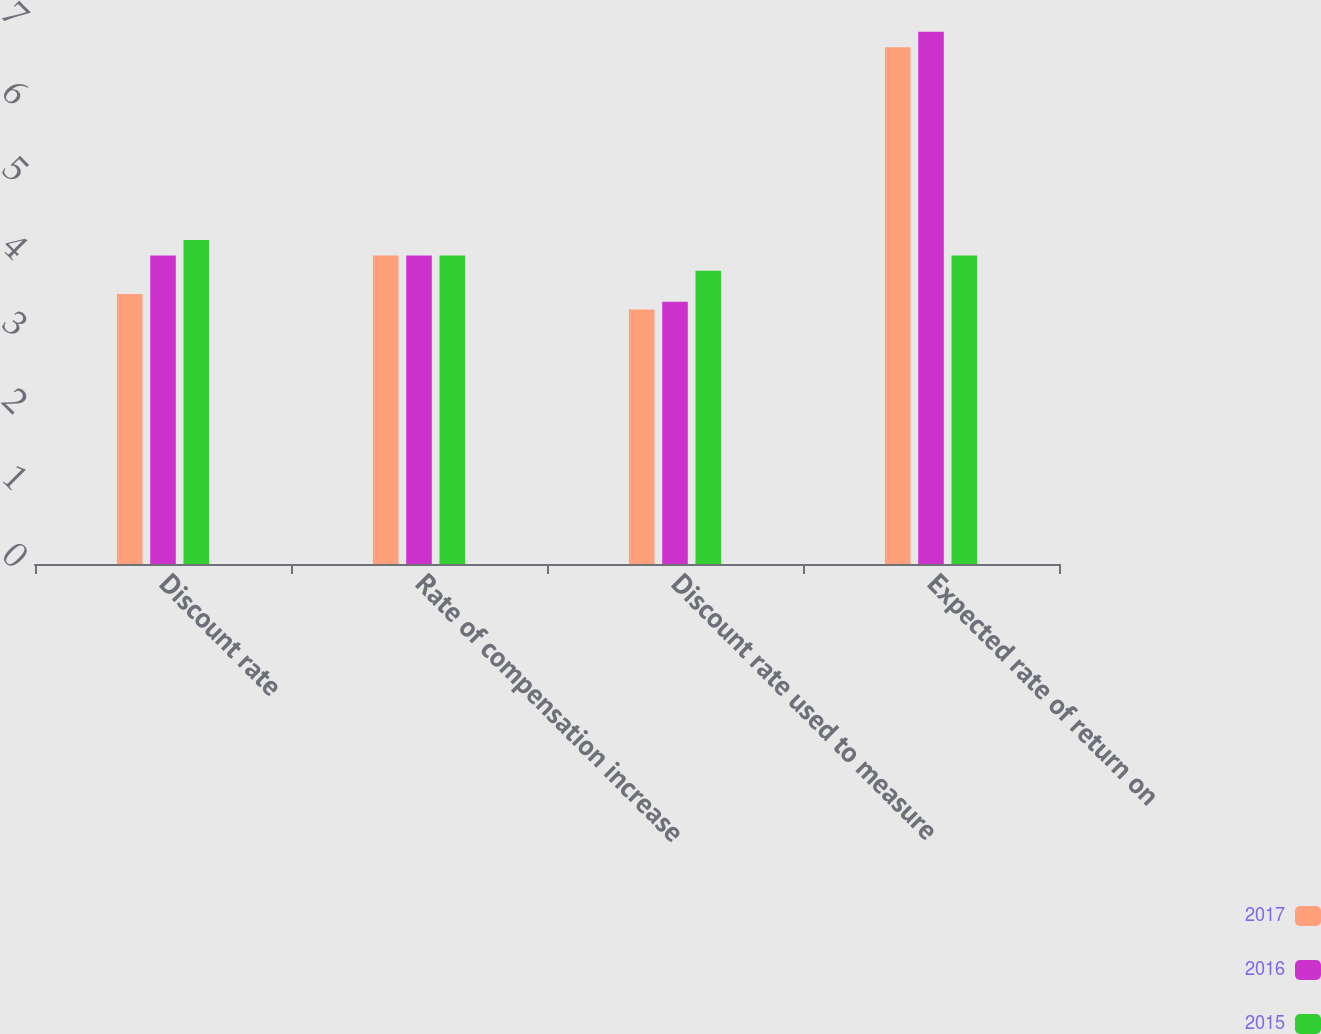<chart> <loc_0><loc_0><loc_500><loc_500><stacked_bar_chart><ecel><fcel>Discount rate<fcel>Rate of compensation increase<fcel>Discount rate used to measure<fcel>Expected rate of return on<nl><fcel>2017<fcel>3.5<fcel>4<fcel>3.3<fcel>6.7<nl><fcel>2016<fcel>4<fcel>4<fcel>3.4<fcel>6.9<nl><fcel>2015<fcel>4.2<fcel>4<fcel>3.8<fcel>4<nl></chart> 